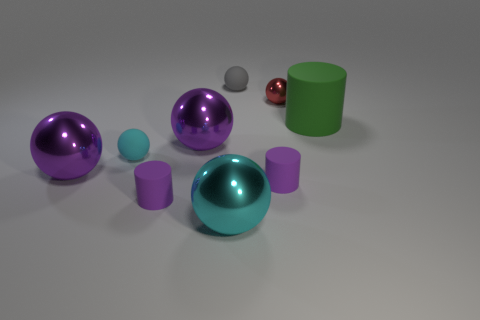What color is the metallic sphere that is the same size as the gray rubber object?
Your answer should be very brief. Red. How many tiny objects are either purple balls or green cubes?
Offer a terse response. 0. Are there an equal number of tiny matte spheres on the left side of the tiny cyan rubber object and large green rubber objects on the left side of the green cylinder?
Ensure brevity in your answer.  Yes. What number of matte things have the same size as the gray matte sphere?
Provide a succinct answer. 3. How many blue things are either small spheres or rubber objects?
Provide a succinct answer. 0. Are there the same number of tiny cyan balls that are to the right of the tiny gray ball and small green metal balls?
Provide a succinct answer. Yes. How big is the cylinder that is on the right side of the small red shiny ball?
Make the answer very short. Large. How many large matte things are the same shape as the red shiny object?
Offer a terse response. 0. What is the tiny thing that is both to the right of the tiny gray object and behind the big green matte cylinder made of?
Provide a short and direct response. Metal. Is the material of the big cyan thing the same as the red thing?
Ensure brevity in your answer.  Yes. 